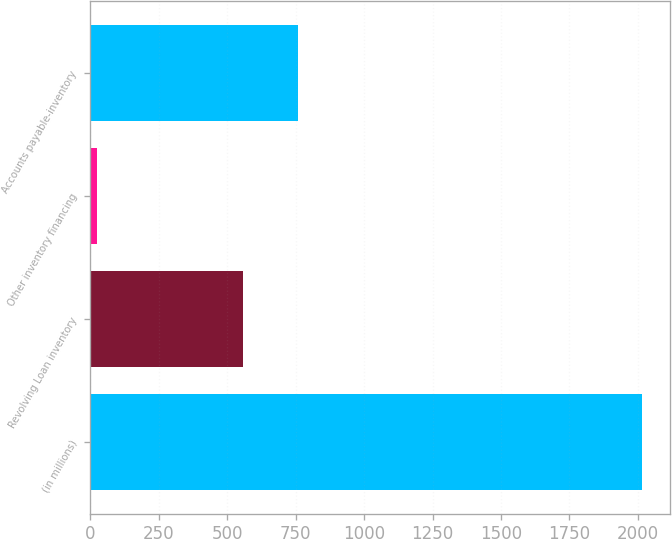Convert chart. <chart><loc_0><loc_0><loc_500><loc_500><bar_chart><fcel>(in millions)<fcel>Revolving Loan inventory<fcel>Other inventory financing<fcel>Accounts payable-inventory<nl><fcel>2016<fcel>558.3<fcel>22.1<fcel>757.69<nl></chart> 